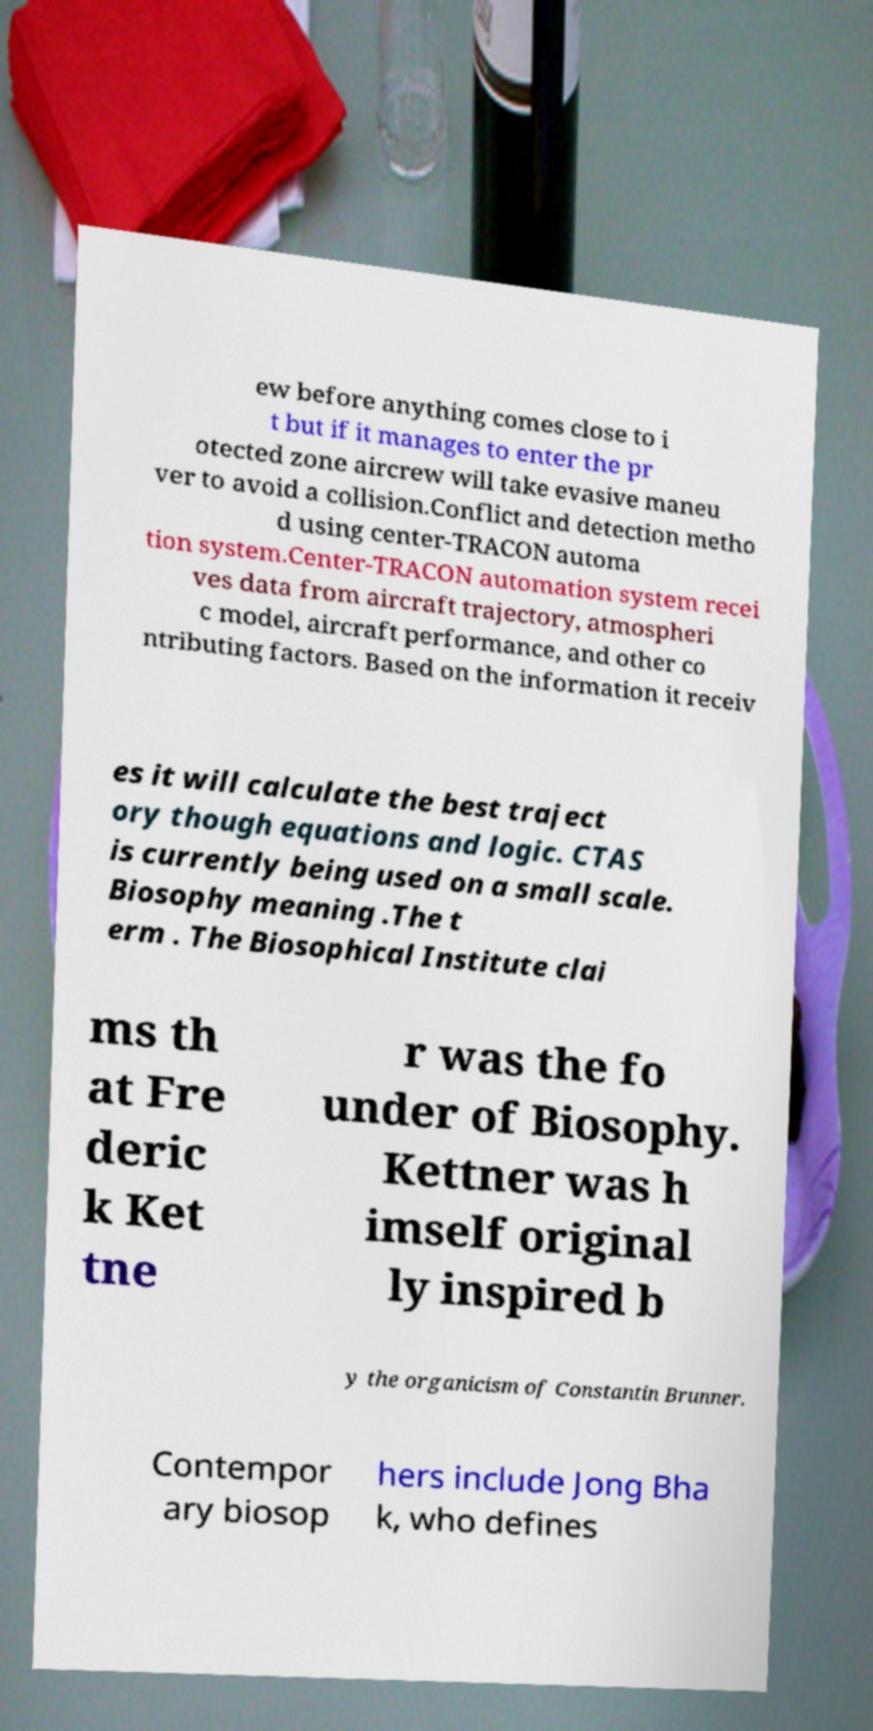For documentation purposes, I need the text within this image transcribed. Could you provide that? ew before anything comes close to i t but if it manages to enter the pr otected zone aircrew will take evasive maneu ver to avoid a collision.Conflict and detection metho d using center-TRACON automa tion system.Center-TRACON automation system recei ves data from aircraft trajectory, atmospheri c model, aircraft performance, and other co ntributing factors. Based on the information it receiv es it will calculate the best traject ory though equations and logic. CTAS is currently being used on a small scale. Biosophy meaning .The t erm . The Biosophical Institute clai ms th at Fre deric k Ket tne r was the fo under of Biosophy. Kettner was h imself original ly inspired b y the organicism of Constantin Brunner. Contempor ary biosop hers include Jong Bha k, who defines 